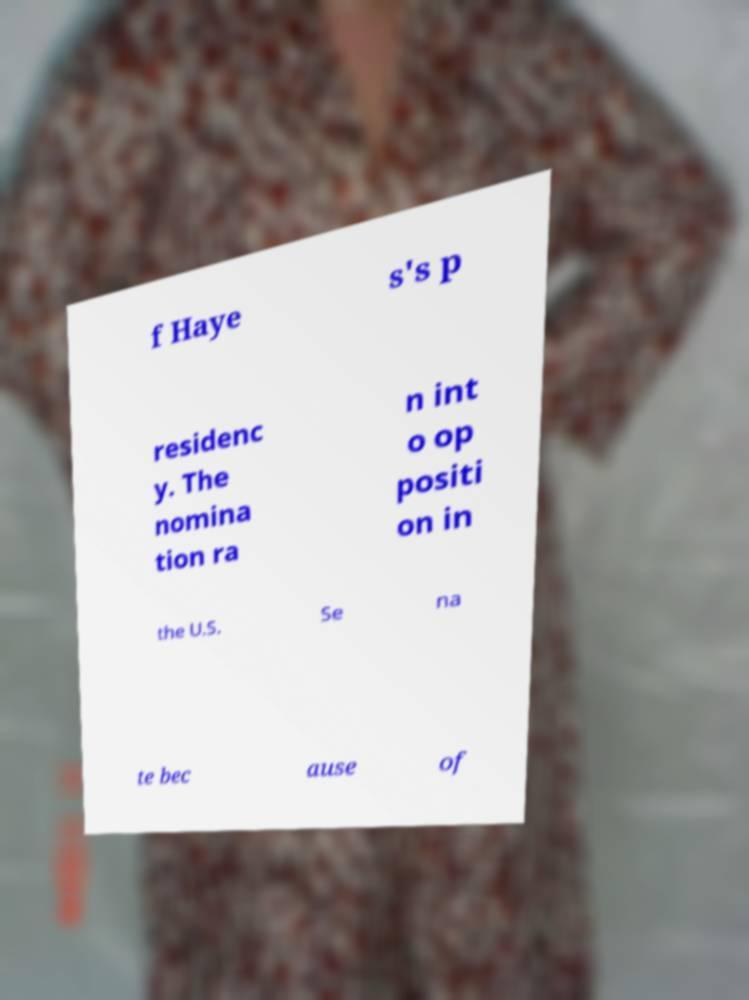Please identify and transcribe the text found in this image. f Haye s's p residenc y. The nomina tion ra n int o op positi on in the U.S. Se na te bec ause of 